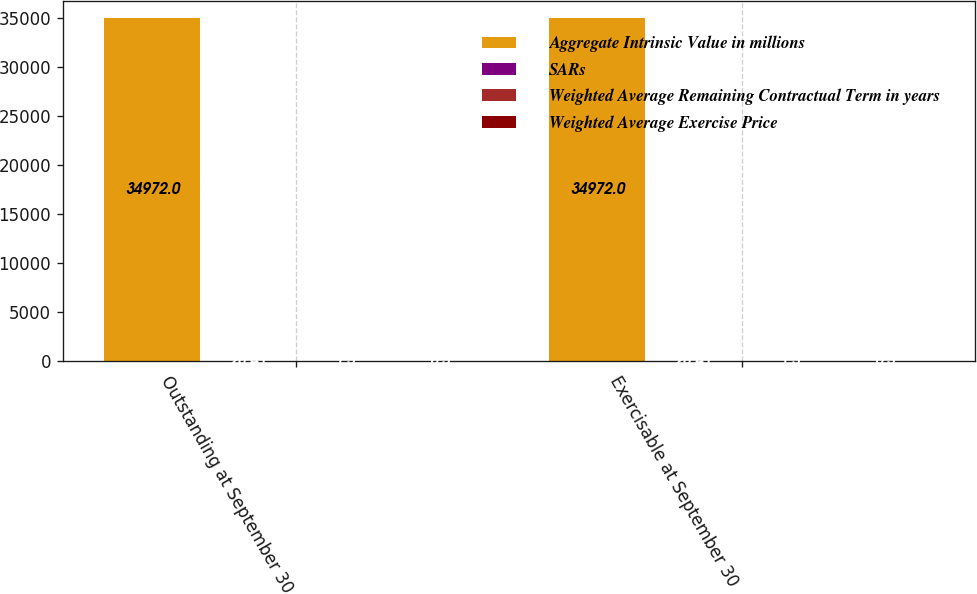Convert chart. <chart><loc_0><loc_0><loc_500><loc_500><stacked_bar_chart><ecel><fcel>Outstanding at September 30<fcel>Exercisable at September 30<nl><fcel>Aggregate Intrinsic Value in millions<fcel>34972<fcel>34972<nl><fcel>SARs<fcel>28.41<fcel>28.41<nl><fcel>Weighted Average Remaining Contractual Term in years<fcel>1.5<fcel>1.5<nl><fcel>Weighted Average Exercise Price<fcel>0.3<fcel>0.3<nl></chart> 